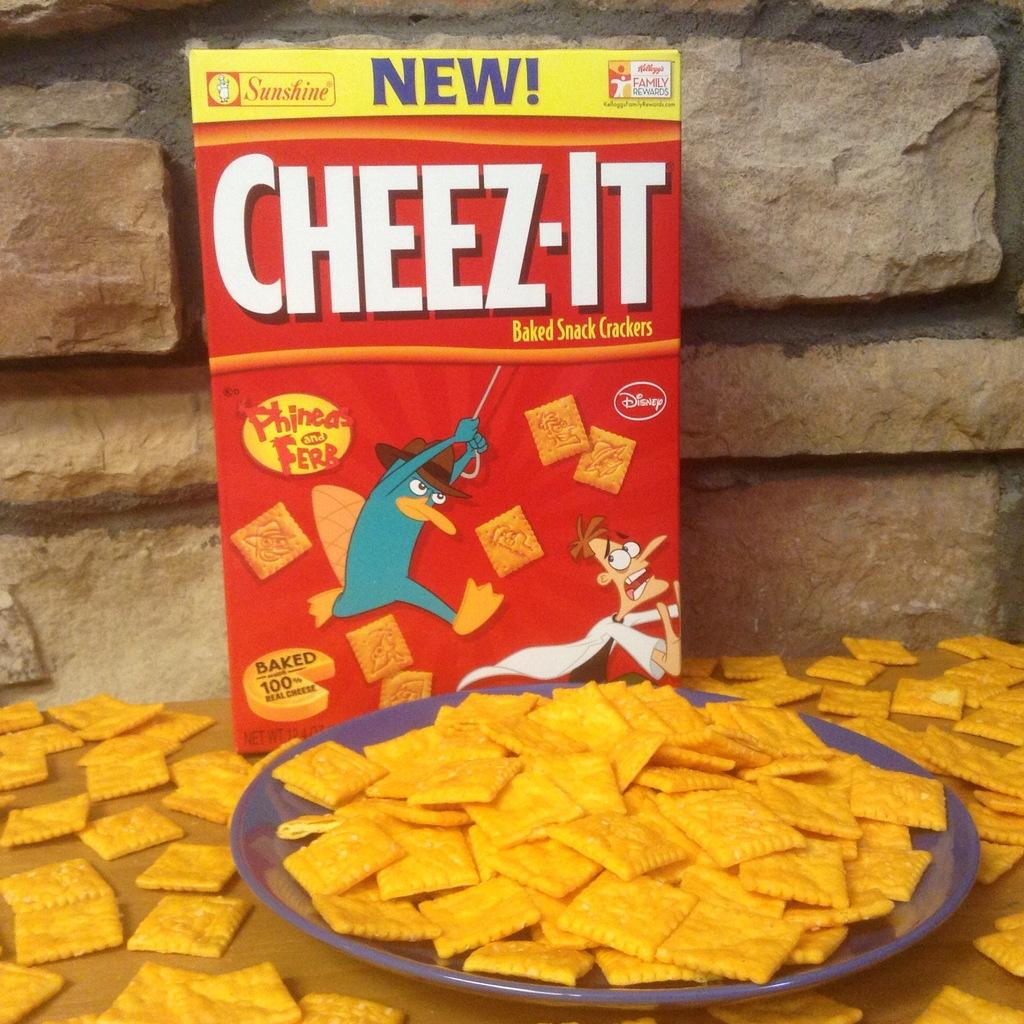<image>
Describe the image concisely. a BOX OF CHEESE-ITS BEHIND A PLATE FULL OF CHEESE-ITS 